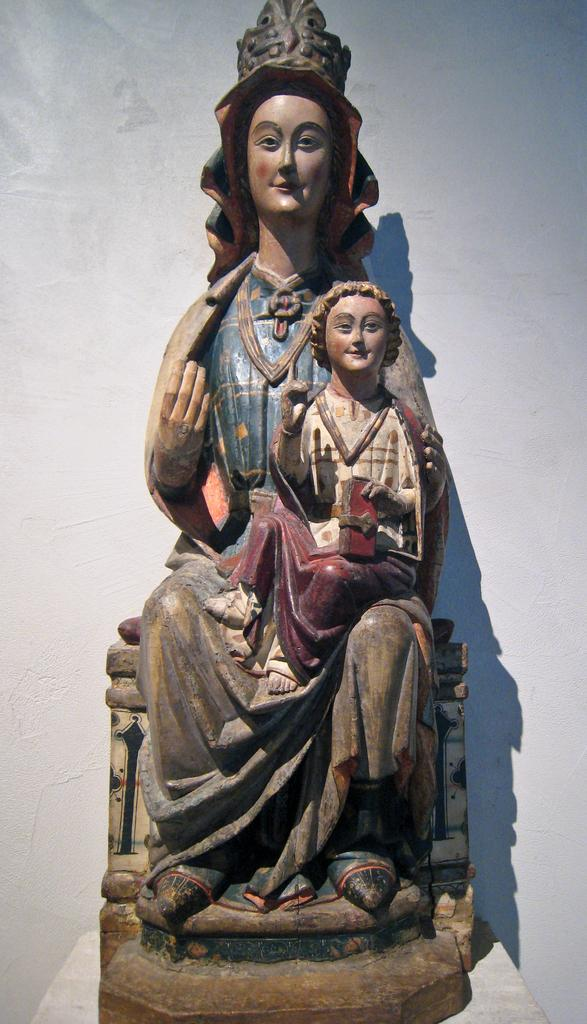What type of art is present in the image? There are sculptures in the image. What color is the background of the image? The background of the image is white. Where is the drain located in the image? There is no drain present in the image. Can you see any bees in the image? There are no bees present in the image. 